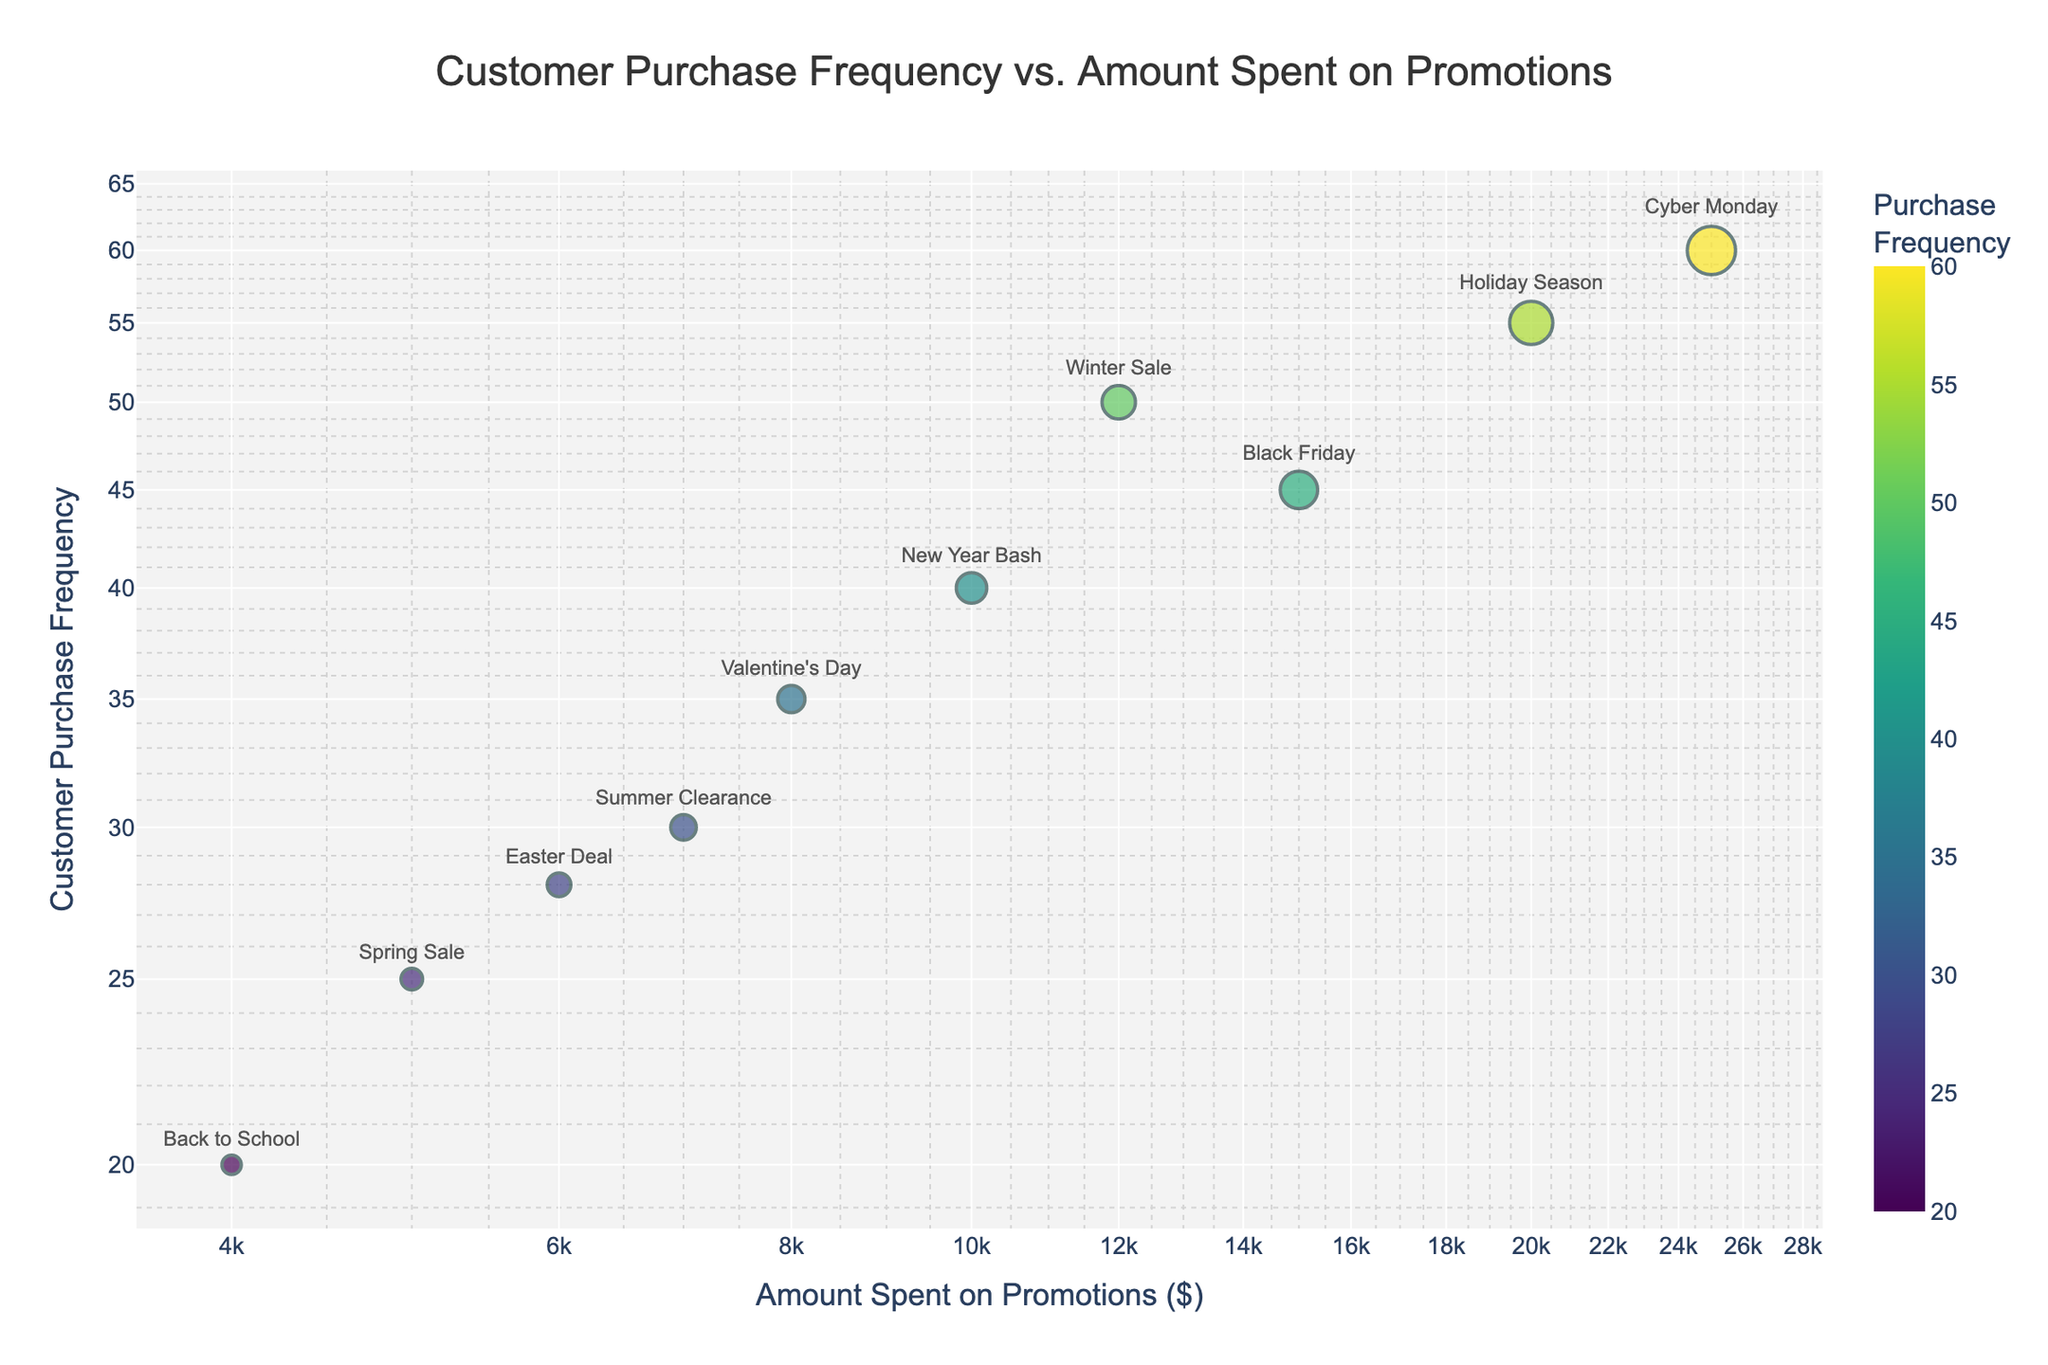What is the title of the figure? The title is displayed at the top of the figure in a larger font. It summarizes what the plot represents.
Answer: Customer Purchase Frequency vs. Amount Spent on Promotions How many marketing campaigns are displayed in the figure? Each data point represents a marketing campaign. Count the number of unique points on the plot.
Answer: 10 Which campaign shows the highest Customer Purchase Frequency? Look for the data point that is positioned highest on the y-axis.
Answer: Cyber Monday Which two campaigns spent the most and least amount on promotions, respectively? Identify the data points farthest to the right (highest amount spent on promotions) and farthest to the left (lowest amount spent on promotions).
Answer: Cyber Monday and Back to School What is the relationship between the amount spent on promotions and customer purchase frequency for major campaigns? Examine the trend of data points, noting that higher amounts spent tend to correlate with higher purchase frequencies.
Answer: Positive correlation What is the average Customer Purchase Frequency for the campaigns that spent over $10,000 on promotions? Calculate the average of the purchase frequencies for campaigns with promotion spending > $10,000 (15, 20, 25). Sum = (15000 + 20000 + 25000) / 3 = 20000; Median = 45
Answer: 45 Which campaign has the largest marker size, and what does it represent? The size of the markers represents the amount spent on promotions. The largest marker corresponds to the highest spending.
Answer: Cyber Monday; $25,000 Is there any campaign with a purchase frequency below 30 and spending more than $5,000 on promotions? Identify campaigns placed below the y=30 line but to the right of the x=5,000 line.
Answer: No Which campaign is closest to the intersection of 1,000 units spent on promotions and 10 units of purchase frequency on log scales? Find the data point nearest to (log 1000, log 10).
Answer: Back to School 